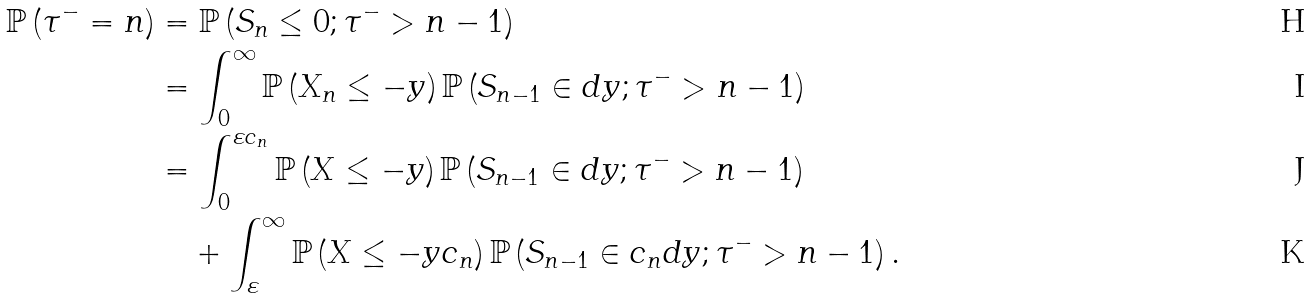Convert formula to latex. <formula><loc_0><loc_0><loc_500><loc_500>\mathbb { P } \left ( \tau ^ { - } = n \right ) & = \mathbb { P } \left ( S _ { n } \leq 0 ; \tau ^ { - } > n - 1 \right ) \\ & = \int _ { 0 } ^ { \infty } \mathbb { P } \left ( X _ { n } \leq - y \right ) \mathbb { P } \left ( S _ { n - 1 } \in d y ; \tau ^ { - } > n - 1 \right ) \\ & = \int _ { 0 } ^ { \varepsilon c _ { n } } \mathbb { P } \left ( X \leq - y \right ) \mathbb { P } \left ( S _ { n - 1 } \in d y ; \tau ^ { - } > n - 1 \right ) \\ & \quad + \int _ { \varepsilon } ^ { \infty } \mathbb { P } \left ( X \leq - y c _ { n } \right ) \mathbb { P } \left ( S _ { n - 1 } \in c _ { n } d y ; \tau ^ { - } > n - 1 \right ) .</formula> 